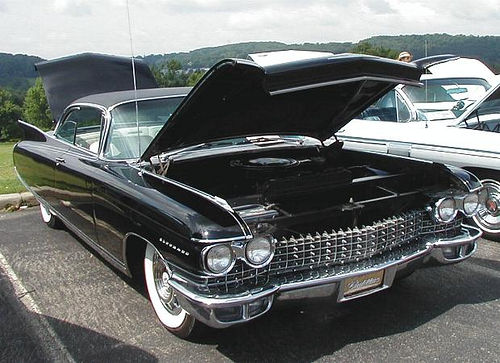Can you describe the vehicle shown in the image? The image showcases a black vintage car, likely from the late 1950s or early 1960s, based on its distinctive tailfins and chrome accents. The car's front hood is open, suggesting that it might be on display at an automobile show. What can you infer about the car's condition? The car appears to be in excellent condition. The paintwork is shiny and well-maintained, the chrome parts are polished with no visible rust, and the overall aesthetic suggests a careful restoration to preserve its classic look. 